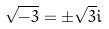Convert formula to latex. <formula><loc_0><loc_0><loc_500><loc_500>\sqrt { - 3 } = \pm \sqrt { 3 } i</formula> 